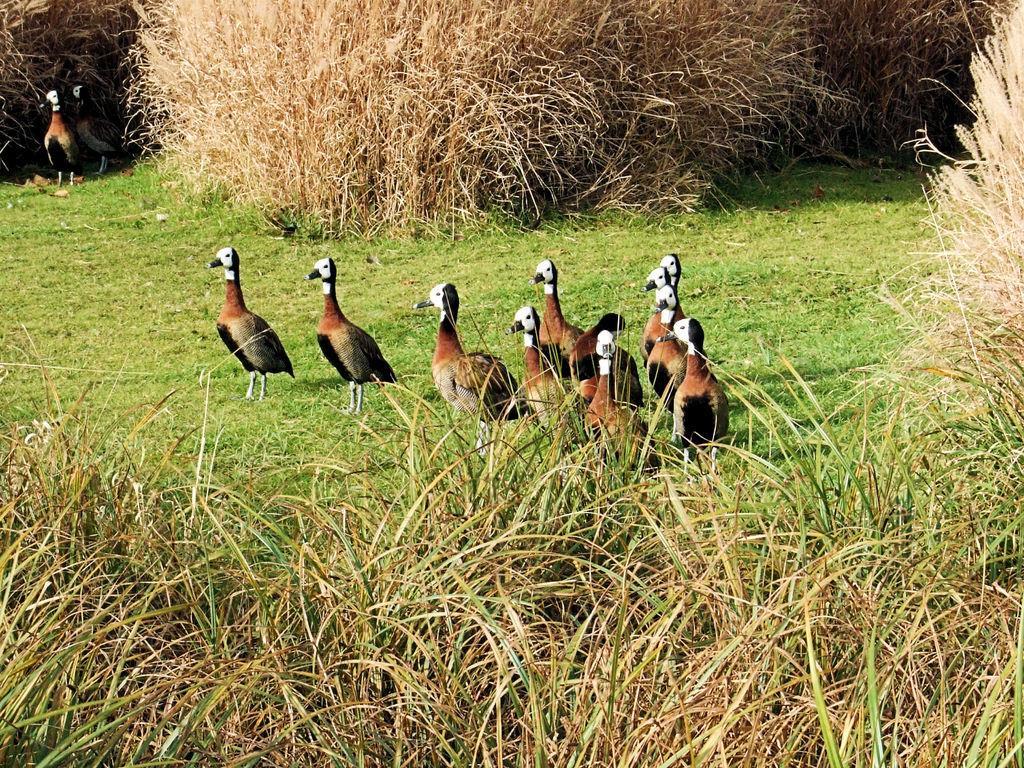Can you describe this image briefly? In this image I can see grass ground in the centre and on it I can see number of birds are standing. I can also see bushes in the front and in the background. 